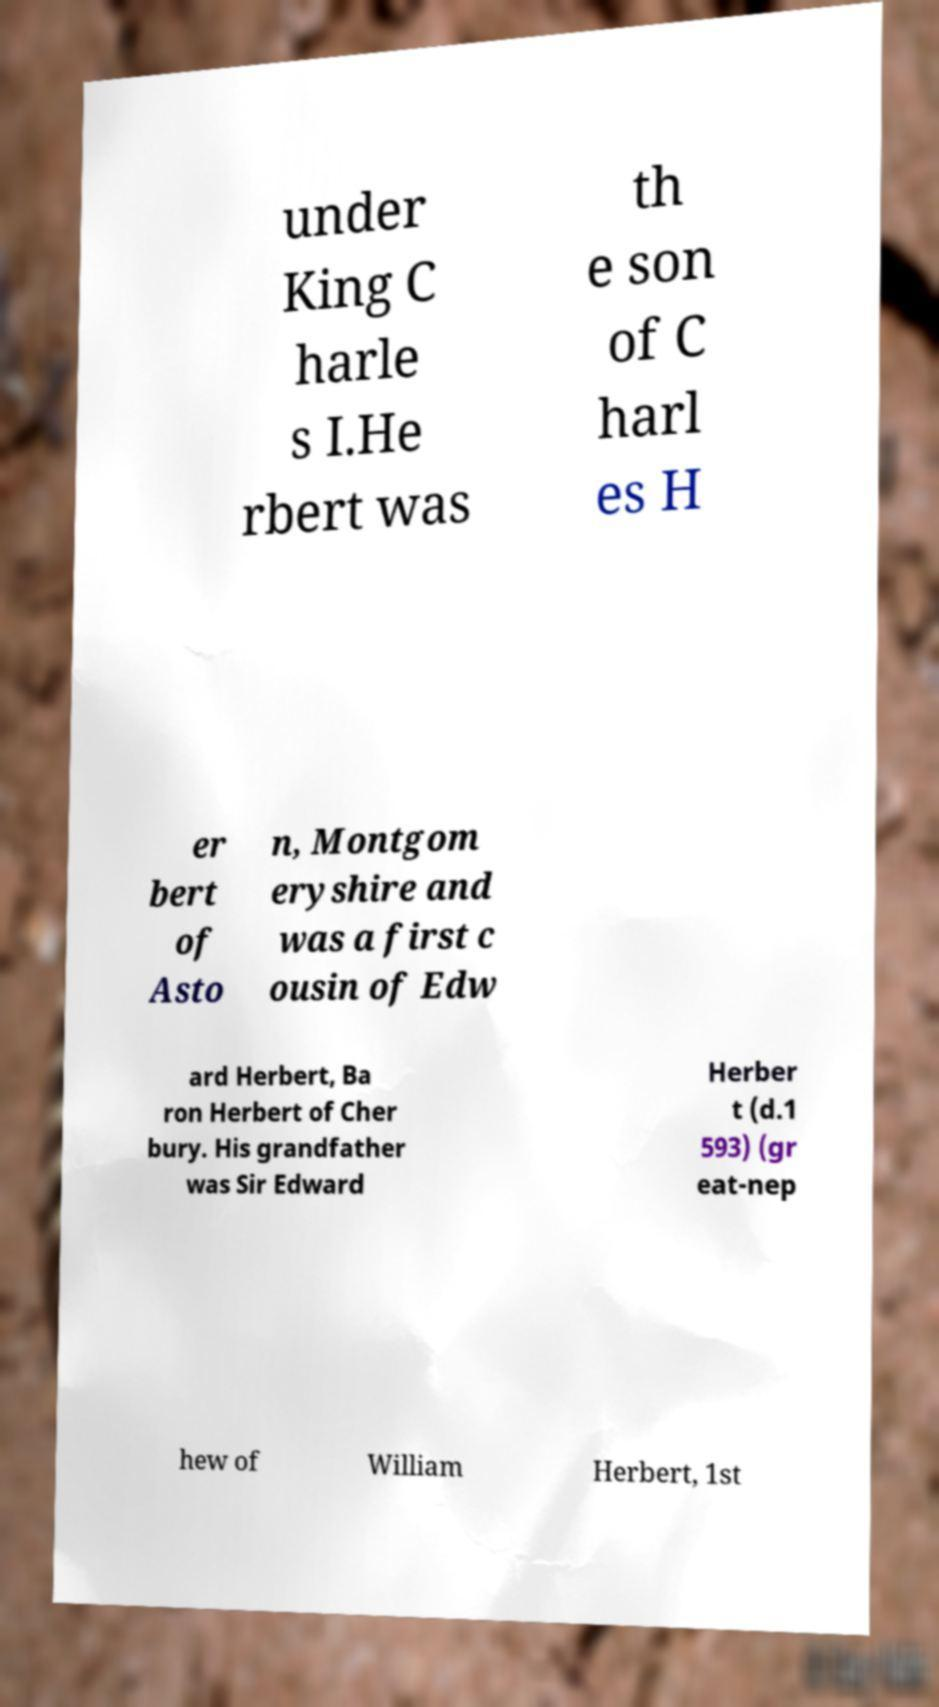Please read and relay the text visible in this image. What does it say? under King C harle s I.He rbert was th e son of C harl es H er bert of Asto n, Montgom eryshire and was a first c ousin of Edw ard Herbert, Ba ron Herbert of Cher bury. His grandfather was Sir Edward Herber t (d.1 593) (gr eat-nep hew of William Herbert, 1st 